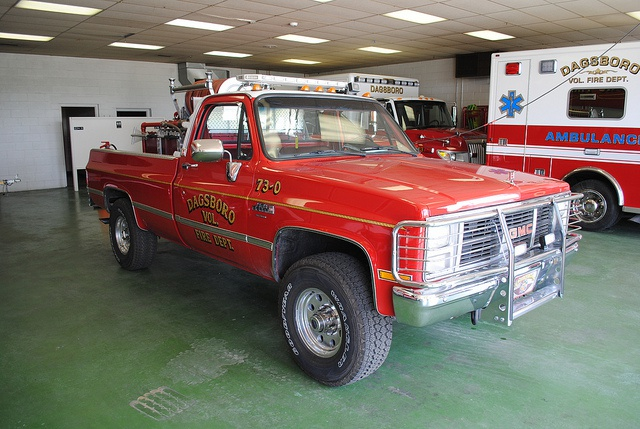Describe the objects in this image and their specific colors. I can see truck in gray, black, white, and maroon tones, truck in gray, lightgray, brown, black, and darkgray tones, and truck in gray, black, darkgray, and maroon tones in this image. 